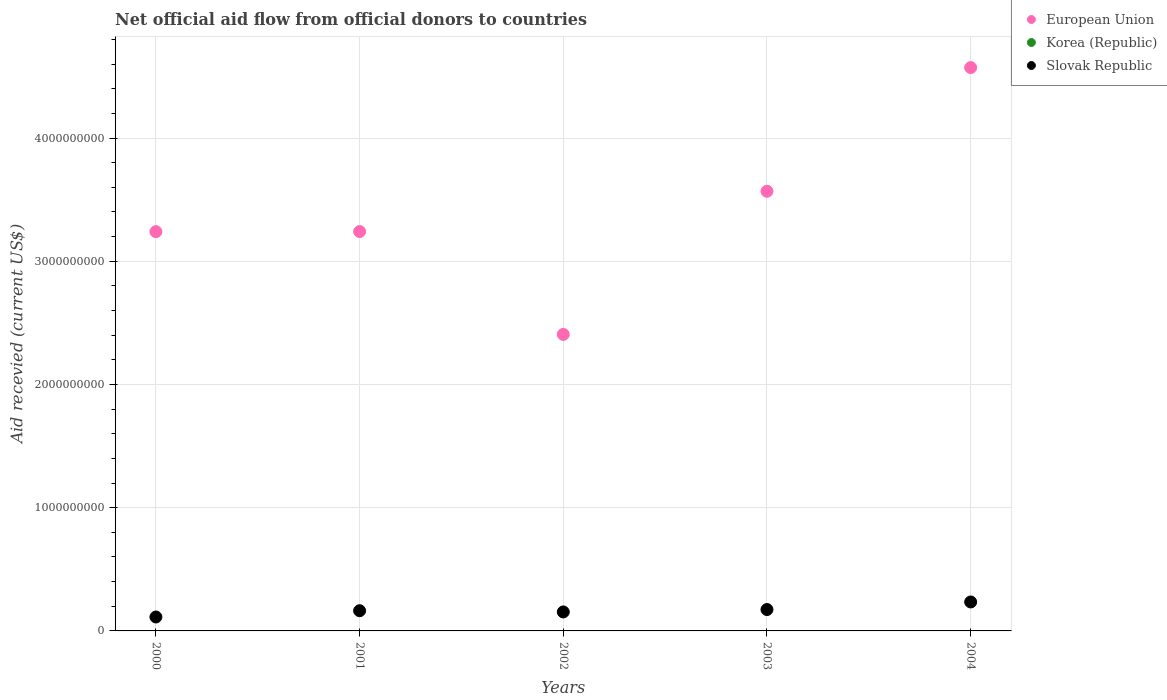Is the number of dotlines equal to the number of legend labels?
Your answer should be very brief. No. What is the total aid received in European Union in 2004?
Offer a very short reply. 4.57e+09. Across all years, what is the maximum total aid received in European Union?
Make the answer very short. 4.57e+09. Across all years, what is the minimum total aid received in Slovak Republic?
Your answer should be very brief. 1.13e+08. What is the total total aid received in European Union in the graph?
Your answer should be very brief. 1.70e+1. What is the difference between the total aid received in European Union in 2001 and that in 2004?
Give a very brief answer. -1.33e+09. What is the difference between the total aid received in Korea (Republic) in 2000 and the total aid received in Slovak Republic in 2001?
Provide a short and direct response. -1.64e+08. What is the average total aid received in Slovak Republic per year?
Keep it short and to the point. 1.68e+08. In the year 2002, what is the difference between the total aid received in European Union and total aid received in Slovak Republic?
Your answer should be very brief. 2.25e+09. In how many years, is the total aid received in Slovak Republic greater than 2000000000 US$?
Give a very brief answer. 0. What is the ratio of the total aid received in Slovak Republic in 2002 to that in 2003?
Your answer should be very brief. 0.89. What is the difference between the highest and the second highest total aid received in European Union?
Give a very brief answer. 1.00e+09. What is the difference between the highest and the lowest total aid received in European Union?
Offer a terse response. 2.17e+09. In how many years, is the total aid received in Slovak Republic greater than the average total aid received in Slovak Republic taken over all years?
Ensure brevity in your answer.  2. Does the total aid received in Slovak Republic monotonically increase over the years?
Keep it short and to the point. No. Is the total aid received in European Union strictly less than the total aid received in Slovak Republic over the years?
Give a very brief answer. No. What is the difference between two consecutive major ticks on the Y-axis?
Your response must be concise. 1.00e+09. Are the values on the major ticks of Y-axis written in scientific E-notation?
Give a very brief answer. No. Where does the legend appear in the graph?
Your answer should be very brief. Top right. How many legend labels are there?
Your answer should be very brief. 3. How are the legend labels stacked?
Ensure brevity in your answer.  Vertical. What is the title of the graph?
Your answer should be compact. Net official aid flow from official donors to countries. Does "Turks and Caicos Islands" appear as one of the legend labels in the graph?
Offer a very short reply. No. What is the label or title of the Y-axis?
Your answer should be compact. Aid recevied (current US$). What is the Aid recevied (current US$) in European Union in 2000?
Offer a very short reply. 3.24e+09. What is the Aid recevied (current US$) of Slovak Republic in 2000?
Make the answer very short. 1.13e+08. What is the Aid recevied (current US$) in European Union in 2001?
Keep it short and to the point. 3.24e+09. What is the Aid recevied (current US$) of Korea (Republic) in 2001?
Ensure brevity in your answer.  0. What is the Aid recevied (current US$) of Slovak Republic in 2001?
Provide a short and direct response. 1.64e+08. What is the Aid recevied (current US$) in European Union in 2002?
Make the answer very short. 2.41e+09. What is the Aid recevied (current US$) in Korea (Republic) in 2002?
Your answer should be very brief. 0. What is the Aid recevied (current US$) of Slovak Republic in 2002?
Your answer should be very brief. 1.54e+08. What is the Aid recevied (current US$) of European Union in 2003?
Your answer should be compact. 3.57e+09. What is the Aid recevied (current US$) in Korea (Republic) in 2003?
Your answer should be very brief. 0. What is the Aid recevied (current US$) of Slovak Republic in 2003?
Provide a succinct answer. 1.74e+08. What is the Aid recevied (current US$) of European Union in 2004?
Offer a terse response. 4.57e+09. What is the Aid recevied (current US$) of Slovak Republic in 2004?
Ensure brevity in your answer.  2.35e+08. Across all years, what is the maximum Aid recevied (current US$) of European Union?
Provide a short and direct response. 4.57e+09. Across all years, what is the maximum Aid recevied (current US$) of Slovak Republic?
Make the answer very short. 2.35e+08. Across all years, what is the minimum Aid recevied (current US$) in European Union?
Offer a terse response. 2.41e+09. Across all years, what is the minimum Aid recevied (current US$) of Slovak Republic?
Your answer should be compact. 1.13e+08. What is the total Aid recevied (current US$) of European Union in the graph?
Ensure brevity in your answer.  1.70e+1. What is the total Aid recevied (current US$) in Korea (Republic) in the graph?
Your answer should be very brief. 0. What is the total Aid recevied (current US$) of Slovak Republic in the graph?
Keep it short and to the point. 8.40e+08. What is the difference between the Aid recevied (current US$) of European Union in 2000 and that in 2001?
Provide a short and direct response. -7.70e+05. What is the difference between the Aid recevied (current US$) in Slovak Republic in 2000 and that in 2001?
Your response must be concise. -5.10e+07. What is the difference between the Aid recevied (current US$) in European Union in 2000 and that in 2002?
Ensure brevity in your answer.  8.34e+08. What is the difference between the Aid recevied (current US$) in Slovak Republic in 2000 and that in 2002?
Keep it short and to the point. -4.11e+07. What is the difference between the Aid recevied (current US$) of European Union in 2000 and that in 2003?
Offer a very short reply. -3.28e+08. What is the difference between the Aid recevied (current US$) in Slovak Republic in 2000 and that in 2003?
Provide a succinct answer. -6.06e+07. What is the difference between the Aid recevied (current US$) of European Union in 2000 and that in 2004?
Make the answer very short. -1.33e+09. What is the difference between the Aid recevied (current US$) in Slovak Republic in 2000 and that in 2004?
Your response must be concise. -1.22e+08. What is the difference between the Aid recevied (current US$) of European Union in 2001 and that in 2002?
Your response must be concise. 8.35e+08. What is the difference between the Aid recevied (current US$) in Slovak Republic in 2001 and that in 2002?
Provide a succinct answer. 9.92e+06. What is the difference between the Aid recevied (current US$) of European Union in 2001 and that in 2003?
Your answer should be very brief. -3.27e+08. What is the difference between the Aid recevied (current US$) in Slovak Republic in 2001 and that in 2003?
Make the answer very short. -9.53e+06. What is the difference between the Aid recevied (current US$) in European Union in 2001 and that in 2004?
Your answer should be very brief. -1.33e+09. What is the difference between the Aid recevied (current US$) of Slovak Republic in 2001 and that in 2004?
Your answer should be very brief. -7.10e+07. What is the difference between the Aid recevied (current US$) in European Union in 2002 and that in 2003?
Keep it short and to the point. -1.16e+09. What is the difference between the Aid recevied (current US$) in Slovak Republic in 2002 and that in 2003?
Provide a succinct answer. -1.94e+07. What is the difference between the Aid recevied (current US$) of European Union in 2002 and that in 2004?
Offer a very short reply. -2.17e+09. What is the difference between the Aid recevied (current US$) in Slovak Republic in 2002 and that in 2004?
Your answer should be compact. -8.09e+07. What is the difference between the Aid recevied (current US$) in European Union in 2003 and that in 2004?
Offer a very short reply. -1.00e+09. What is the difference between the Aid recevied (current US$) in Slovak Republic in 2003 and that in 2004?
Give a very brief answer. -6.14e+07. What is the difference between the Aid recevied (current US$) in European Union in 2000 and the Aid recevied (current US$) in Slovak Republic in 2001?
Ensure brevity in your answer.  3.08e+09. What is the difference between the Aid recevied (current US$) in European Union in 2000 and the Aid recevied (current US$) in Slovak Republic in 2002?
Offer a very short reply. 3.09e+09. What is the difference between the Aid recevied (current US$) of European Union in 2000 and the Aid recevied (current US$) of Slovak Republic in 2003?
Offer a very short reply. 3.07e+09. What is the difference between the Aid recevied (current US$) of European Union in 2000 and the Aid recevied (current US$) of Slovak Republic in 2004?
Provide a short and direct response. 3.01e+09. What is the difference between the Aid recevied (current US$) in European Union in 2001 and the Aid recevied (current US$) in Slovak Republic in 2002?
Offer a terse response. 3.09e+09. What is the difference between the Aid recevied (current US$) of European Union in 2001 and the Aid recevied (current US$) of Slovak Republic in 2003?
Your response must be concise. 3.07e+09. What is the difference between the Aid recevied (current US$) in European Union in 2001 and the Aid recevied (current US$) in Slovak Republic in 2004?
Provide a short and direct response. 3.01e+09. What is the difference between the Aid recevied (current US$) in European Union in 2002 and the Aid recevied (current US$) in Slovak Republic in 2003?
Give a very brief answer. 2.23e+09. What is the difference between the Aid recevied (current US$) in European Union in 2002 and the Aid recevied (current US$) in Slovak Republic in 2004?
Your answer should be compact. 2.17e+09. What is the difference between the Aid recevied (current US$) in European Union in 2003 and the Aid recevied (current US$) in Slovak Republic in 2004?
Offer a terse response. 3.33e+09. What is the average Aid recevied (current US$) of European Union per year?
Your answer should be very brief. 3.41e+09. What is the average Aid recevied (current US$) in Slovak Republic per year?
Offer a very short reply. 1.68e+08. In the year 2000, what is the difference between the Aid recevied (current US$) in European Union and Aid recevied (current US$) in Slovak Republic?
Your answer should be very brief. 3.13e+09. In the year 2001, what is the difference between the Aid recevied (current US$) of European Union and Aid recevied (current US$) of Slovak Republic?
Ensure brevity in your answer.  3.08e+09. In the year 2002, what is the difference between the Aid recevied (current US$) in European Union and Aid recevied (current US$) in Slovak Republic?
Ensure brevity in your answer.  2.25e+09. In the year 2003, what is the difference between the Aid recevied (current US$) in European Union and Aid recevied (current US$) in Slovak Republic?
Provide a short and direct response. 3.39e+09. In the year 2004, what is the difference between the Aid recevied (current US$) in European Union and Aid recevied (current US$) in Slovak Republic?
Offer a very short reply. 4.34e+09. What is the ratio of the Aid recevied (current US$) in Slovak Republic in 2000 to that in 2001?
Your answer should be very brief. 0.69. What is the ratio of the Aid recevied (current US$) of European Union in 2000 to that in 2002?
Your answer should be compact. 1.35. What is the ratio of the Aid recevied (current US$) in Slovak Republic in 2000 to that in 2002?
Provide a short and direct response. 0.73. What is the ratio of the Aid recevied (current US$) of European Union in 2000 to that in 2003?
Your answer should be compact. 0.91. What is the ratio of the Aid recevied (current US$) in Slovak Republic in 2000 to that in 2003?
Keep it short and to the point. 0.65. What is the ratio of the Aid recevied (current US$) of European Union in 2000 to that in 2004?
Make the answer very short. 0.71. What is the ratio of the Aid recevied (current US$) of Slovak Republic in 2000 to that in 2004?
Your answer should be very brief. 0.48. What is the ratio of the Aid recevied (current US$) in European Union in 2001 to that in 2002?
Provide a succinct answer. 1.35. What is the ratio of the Aid recevied (current US$) in Slovak Republic in 2001 to that in 2002?
Provide a succinct answer. 1.06. What is the ratio of the Aid recevied (current US$) of European Union in 2001 to that in 2003?
Offer a very short reply. 0.91. What is the ratio of the Aid recevied (current US$) of Slovak Republic in 2001 to that in 2003?
Your answer should be very brief. 0.95. What is the ratio of the Aid recevied (current US$) in European Union in 2001 to that in 2004?
Your answer should be very brief. 0.71. What is the ratio of the Aid recevied (current US$) in Slovak Republic in 2001 to that in 2004?
Offer a terse response. 0.7. What is the ratio of the Aid recevied (current US$) in European Union in 2002 to that in 2003?
Your answer should be very brief. 0.67. What is the ratio of the Aid recevied (current US$) in Slovak Republic in 2002 to that in 2003?
Your answer should be compact. 0.89. What is the ratio of the Aid recevied (current US$) in European Union in 2002 to that in 2004?
Offer a very short reply. 0.53. What is the ratio of the Aid recevied (current US$) in Slovak Republic in 2002 to that in 2004?
Offer a terse response. 0.66. What is the ratio of the Aid recevied (current US$) of European Union in 2003 to that in 2004?
Ensure brevity in your answer.  0.78. What is the ratio of the Aid recevied (current US$) of Slovak Republic in 2003 to that in 2004?
Offer a very short reply. 0.74. What is the difference between the highest and the second highest Aid recevied (current US$) of European Union?
Offer a very short reply. 1.00e+09. What is the difference between the highest and the second highest Aid recevied (current US$) in Slovak Republic?
Provide a short and direct response. 6.14e+07. What is the difference between the highest and the lowest Aid recevied (current US$) in European Union?
Offer a very short reply. 2.17e+09. What is the difference between the highest and the lowest Aid recevied (current US$) in Slovak Republic?
Give a very brief answer. 1.22e+08. 